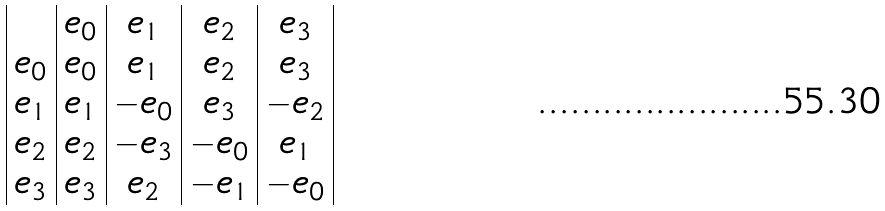Convert formula to latex. <formula><loc_0><loc_0><loc_500><loc_500>\begin{array} { | c | c | c | c | c | } & e _ { 0 } & e _ { 1 } & e _ { 2 } & e _ { 3 } \\ e _ { 0 } & e _ { 0 } & e _ { 1 } & e _ { 2 } & e _ { 3 } \\ e _ { 1 } & e _ { 1 } & - e _ { 0 } & e _ { 3 } & - e _ { 2 } \\ e _ { 2 } & e _ { 2 } & - e _ { 3 } & - e _ { 0 } & e _ { 1 } \\ e _ { 3 } & e _ { 3 } & e _ { 2 } & - e _ { 1 } & - e _ { 0 } \\ \end{array}</formula> 